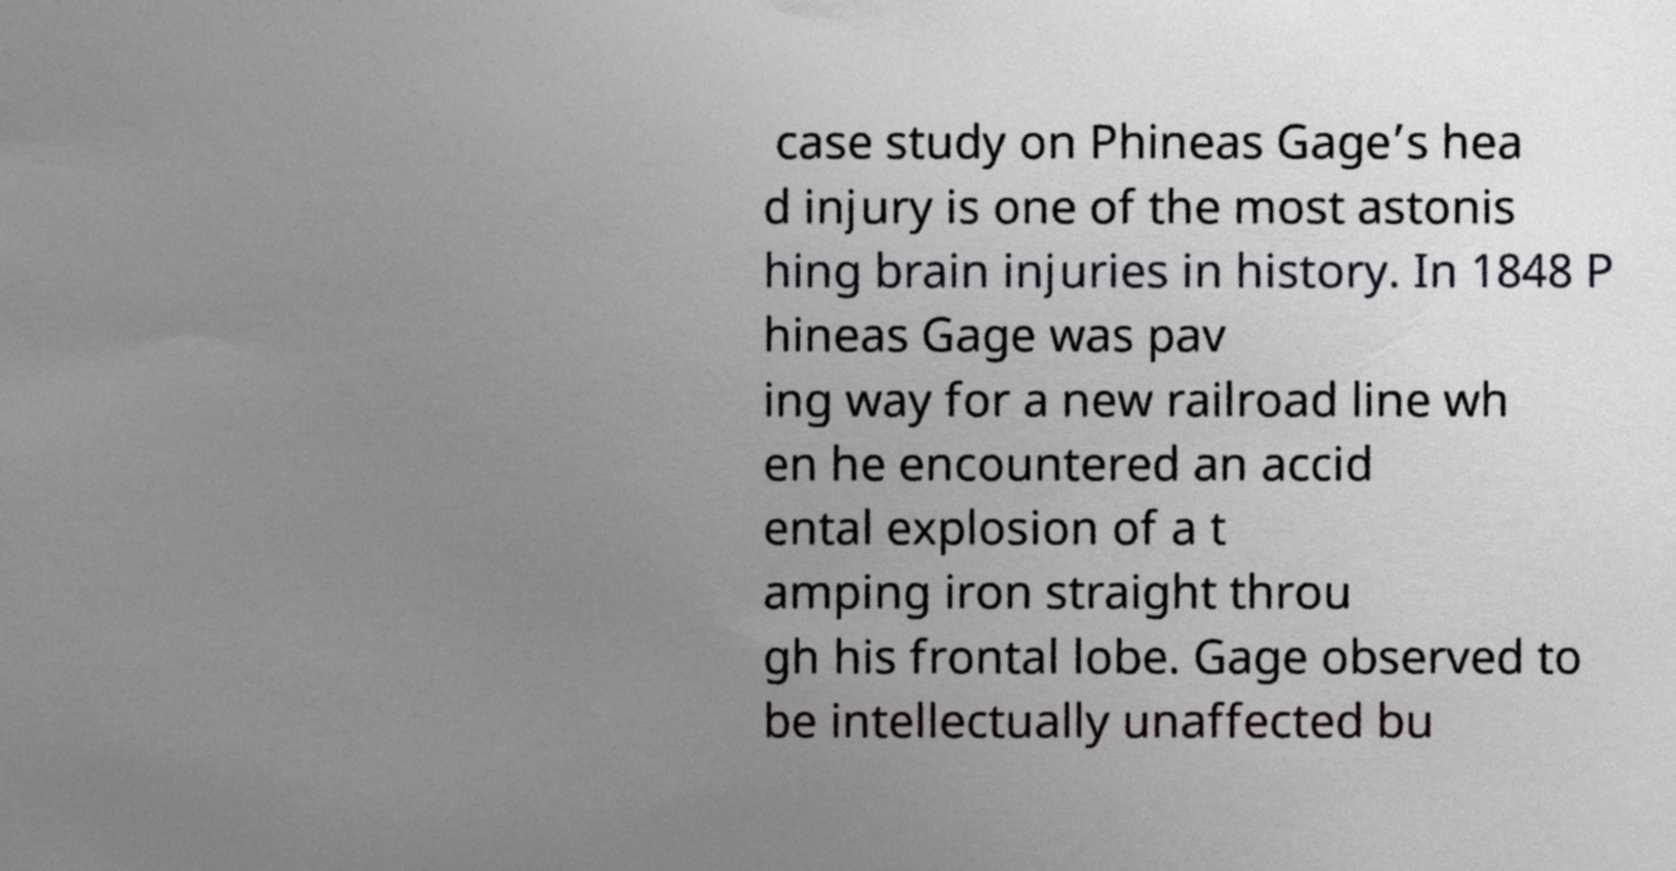Can you accurately transcribe the text from the provided image for me? case study on Phineas Gage’s hea d injury is one of the most astonis hing brain injuries in history. In 1848 P hineas Gage was pav ing way for a new railroad line wh en he encountered an accid ental explosion of a t amping iron straight throu gh his frontal lobe. Gage observed to be intellectually unaffected bu 